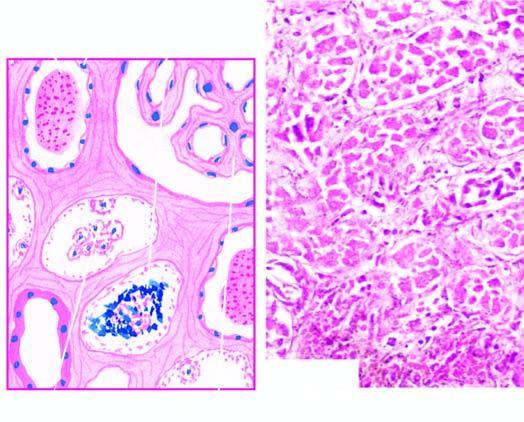what contain casts and the regenerating flat epithelium lines the necrosed tubule?
Answer the question using a single word or phrase. Tubular lumina 